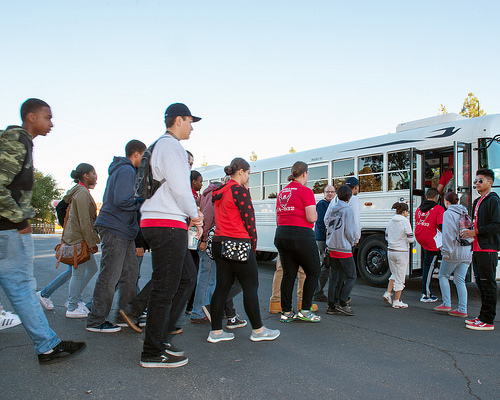<image>
Can you confirm if the shoes is on the person? No. The shoes is not positioned on the person. They may be near each other, but the shoes is not supported by or resting on top of the person. 